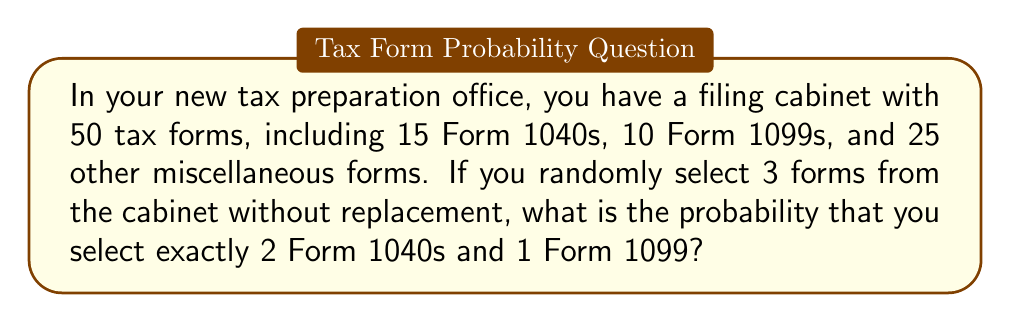Solve this math problem. Let's approach this step-by-step using the concept of combinations:

1) First, we need to calculate the total number of ways to select 3 forms out of 50:
   $$\binom{50}{3} = \frac{50!}{3!(50-3)!} = \frac{50!}{3!47!} = 19,600$$

2) Now, we need to calculate the number of ways to select:
   - 2 Form 1040s out of 15: $\binom{15}{2}$
   - 1 Form 1099 out of 10: $\binom{10}{1}$

3) Calculate these combinations:
   $$\binom{15}{2} = \frac{15!}{2!(15-2)!} = \frac{15!}{2!13!} = 105$$
   $$\binom{10}{1} = \frac{10!}{1!(10-1)!} = \frac{10!}{1!9!} = 10$$

4) The total number of favorable outcomes is the product of these combinations:
   $$105 \times 10 = 1,050$$

5) The probability is the number of favorable outcomes divided by the total number of possible outcomes:
   $$P(\text{2 Form 1040s and 1 Form 1099}) = \frac{1,050}{19,600} = \frac{21}{392} \approx 0.0536$$
Answer: $\frac{21}{392}$ 